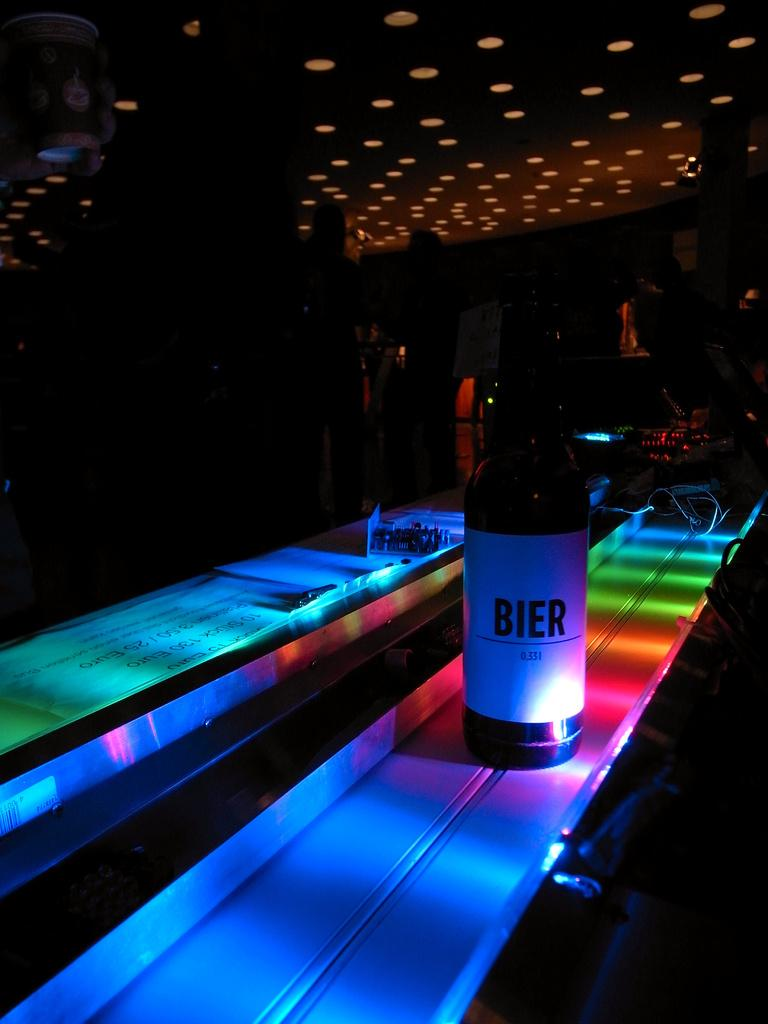<image>
Offer a succinct explanation of the picture presented. A bottle labelde bier sits under colorful lights. 